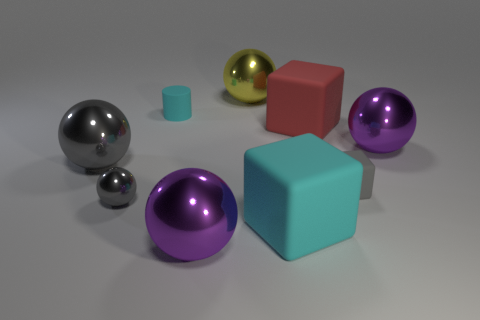Subtract 1 balls. How many balls are left? 4 Subtract all yellow spheres. How many spheres are left? 4 Subtract all yellow metal spheres. How many spheres are left? 4 Subtract all red balls. Subtract all gray cylinders. How many balls are left? 5 Add 1 large red metallic spheres. How many objects exist? 10 Subtract all spheres. How many objects are left? 4 Subtract 0 purple cylinders. How many objects are left? 9 Subtract all yellow objects. Subtract all big red matte blocks. How many objects are left? 7 Add 5 big metal balls. How many big metal balls are left? 9 Add 9 big red matte objects. How many big red matte objects exist? 10 